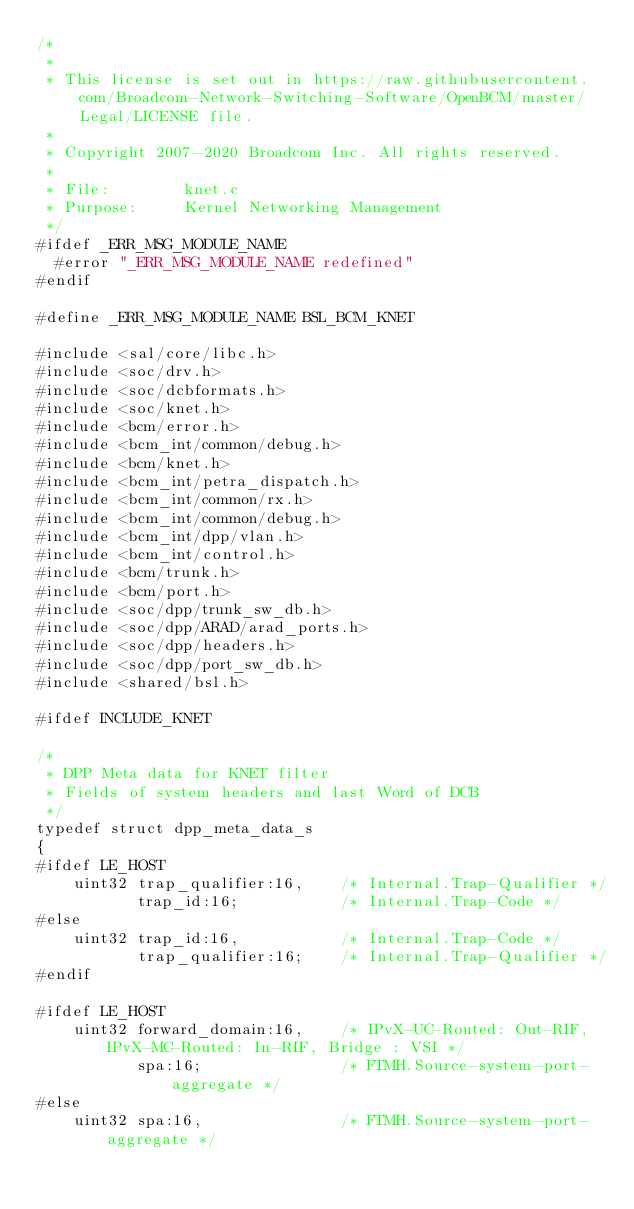<code> <loc_0><loc_0><loc_500><loc_500><_C_>/*
 * 
 * This license is set out in https://raw.githubusercontent.com/Broadcom-Network-Switching-Software/OpenBCM/master/Legal/LICENSE file.
 * 
 * Copyright 2007-2020 Broadcom Inc. All rights reserved.
 *
 * File:        knet.c
 * Purpose:     Kernel Networking Management
 */
#ifdef _ERR_MSG_MODULE_NAME
  #error "_ERR_MSG_MODULE_NAME redefined"
#endif

#define _ERR_MSG_MODULE_NAME BSL_BCM_KNET

#include <sal/core/libc.h>
#include <soc/drv.h>
#include <soc/dcbformats.h>
#include <soc/knet.h>
#include <bcm/error.h>
#include <bcm_int/common/debug.h>
#include <bcm/knet.h>
#include <bcm_int/petra_dispatch.h>
#include <bcm_int/common/rx.h>
#include <bcm_int/common/debug.h>
#include <bcm_int/dpp/vlan.h>
#include <bcm_int/control.h>
#include <bcm/trunk.h>
#include <bcm/port.h>
#include <soc/dpp/trunk_sw_db.h>
#include <soc/dpp/ARAD/arad_ports.h>
#include <soc/dpp/headers.h>
#include <soc/dpp/port_sw_db.h>
#include <shared/bsl.h>

#ifdef INCLUDE_KNET

/*
 * DPP Meta data for KNET filter
 * Fields of system headers and last Word of DCB
 */
typedef struct dpp_meta_data_s
{
#ifdef LE_HOST
    uint32 trap_qualifier:16,    /* Internal.Trap-Qualifier */
           trap_id:16;           /* Internal.Trap-Code */
#else
    uint32 trap_id:16,           /* Internal.Trap-Code */
           trap_qualifier:16;    /* Internal.Trap-Qualifier */
#endif

#ifdef LE_HOST
    uint32 forward_domain:16,    /* IPvX-UC-Routed: Out-RIF, IPvX-MC-Routed: In-RIF, Bridge : VSI */
           spa:16;               /* FTMH.Source-system-port-aggregate */
#else
    uint32 spa:16,               /* FTMH.Source-system-port-aggregate */</code> 